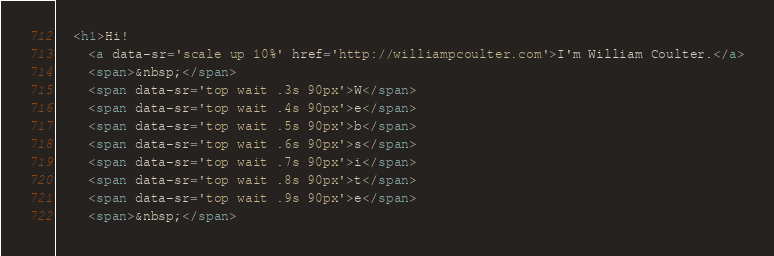Convert code to text. <code><loc_0><loc_0><loc_500><loc_500><_HTML_>  <h1>Hi!
    <a data-sr='scale up 10%' href='http://williampcoulter.com'>I'm William Coulter.</a>
    <span>&nbsp;</span>
    <span data-sr='top wait .3s 90px'>W</span>
    <span data-sr='top wait .4s 90px'>e</span>
    <span data-sr='top wait .5s 90px'>b</span>
    <span data-sr='top wait .6s 90px'>s</span>
    <span data-sr='top wait .7s 90px'>i</span>
    <span data-sr='top wait .8s 90px'>t</span>
    <span data-sr='top wait .9s 90px'>e</span>
    <span>&nbsp;</span></code> 